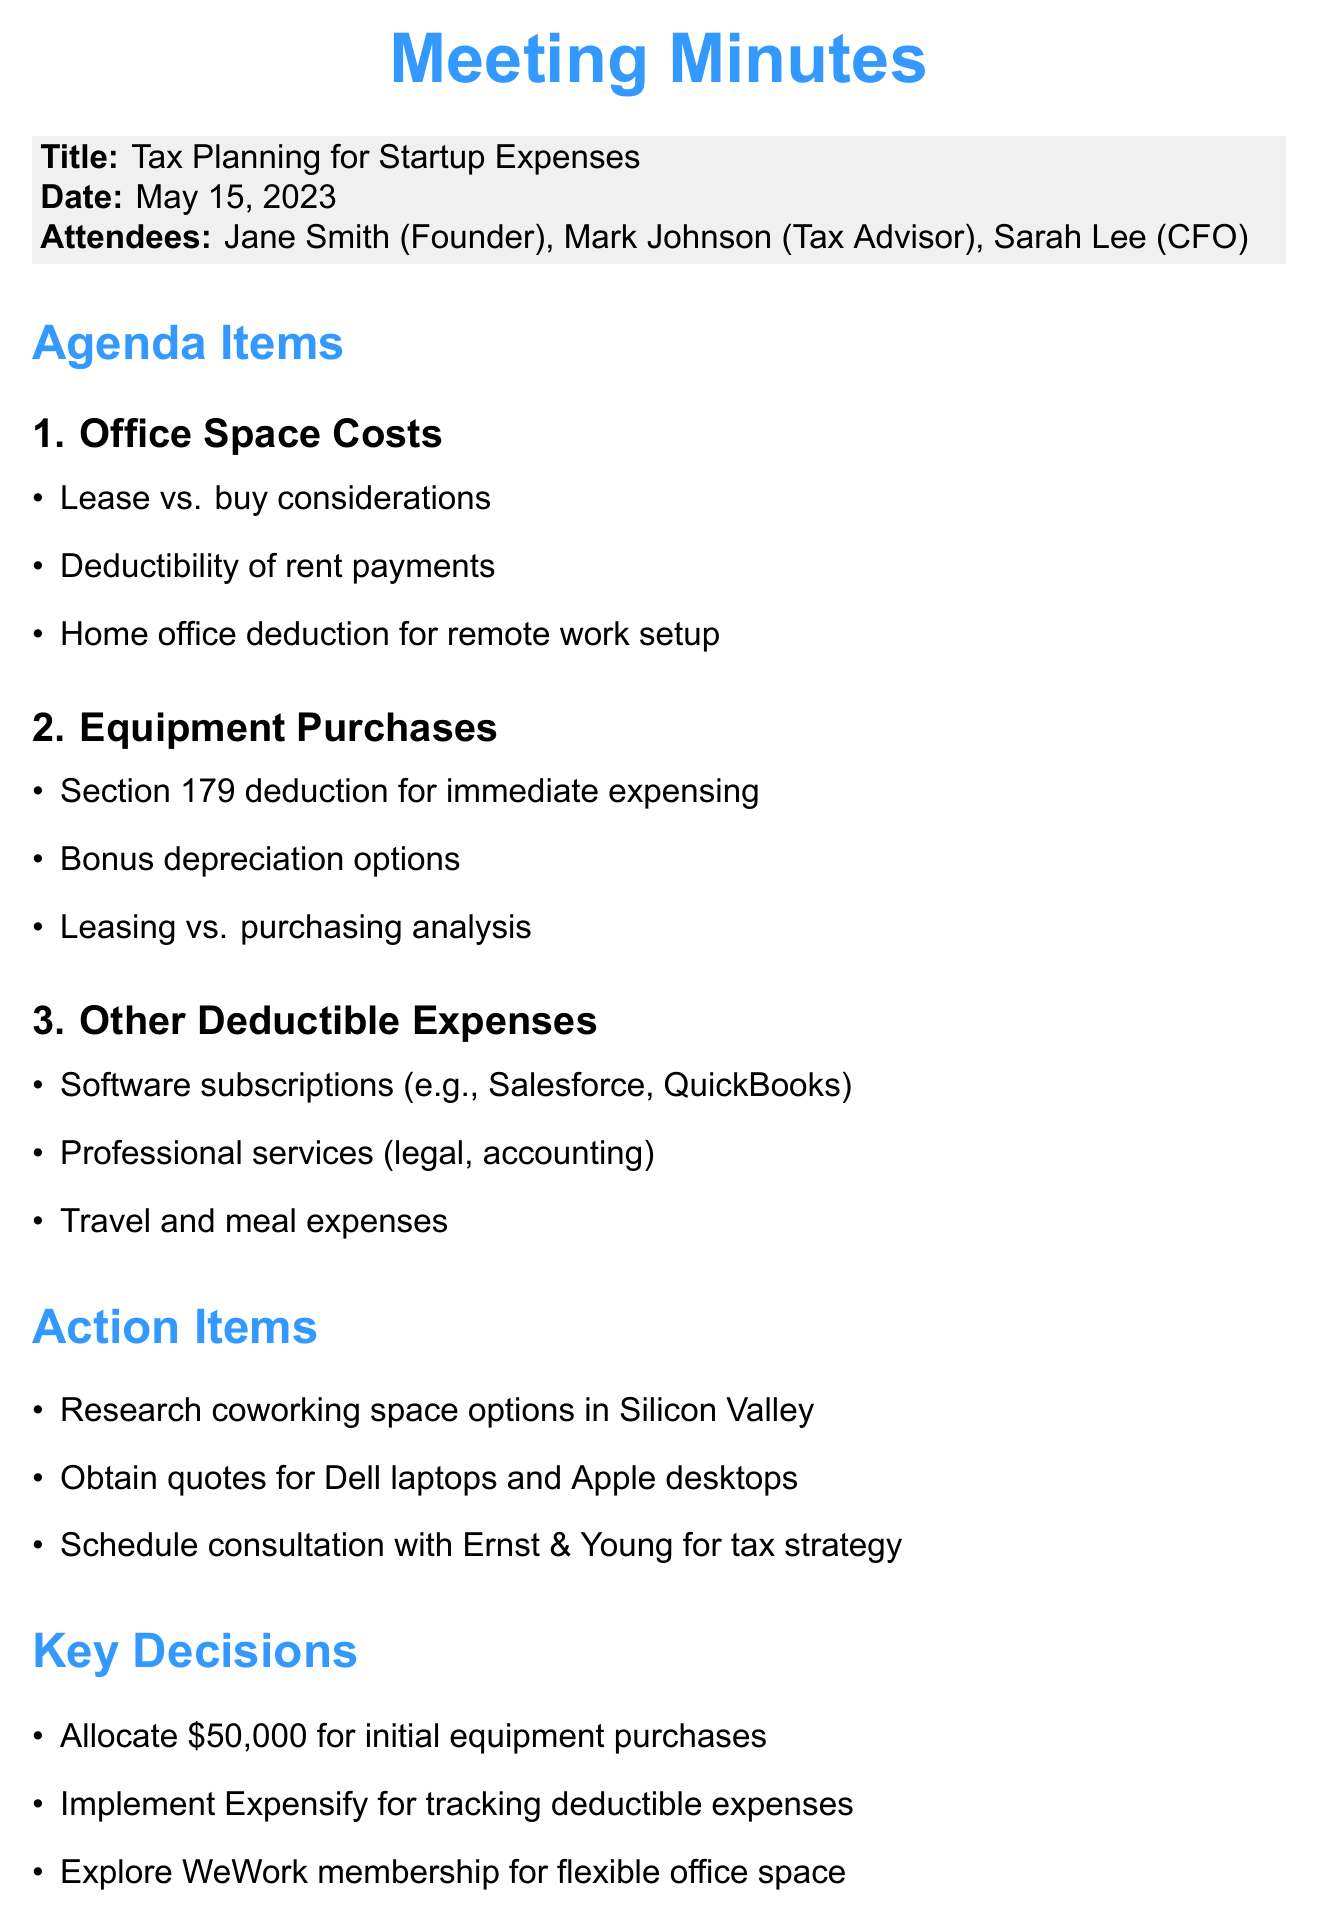What is the date of the meeting? The meeting took place on May 15, 2023.
Answer: May 15, 2023 Who is the tax advisor present at the meeting? Mark Johnson is listed as the tax advisor in the attendees section.
Answer: Mark Johnson What budget is allocated for initial equipment purchases? The document states that $50,000 is allocated for initial equipment purchases.
Answer: $50,000 What is one of the action items mentioned regarding office space? The action item includes researching coworking space options in Silicon Valley.
Answer: Research coworking space options in Silicon Valley What software is suggested for tracking deductible expenses? The document mentions implementing Expensify for tracking deductible expenses.
Answer: Expensify Which discussion topic includes the Section 179 deduction? The discussion on Equipment Purchases includes the Section 179 deduction as a key point.
Answer: Equipment Purchases What professional services are identified as deductible expenses? The meeting minutes highlight legal and accounting services as deductible expenses.
Answer: Legal, accounting What is one of the key points related to office space costs? The deductibility of rent payments is one of the key points related to office space costs.
Answer: Deductibility of rent payments Which membership is explored for flexible office space? The attendees discussed exploring a WeWork membership for flexible office space.
Answer: WeWork membership 